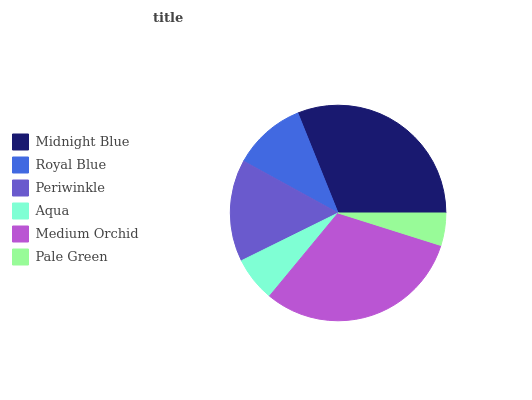Is Pale Green the minimum?
Answer yes or no. Yes. Is Medium Orchid the maximum?
Answer yes or no. Yes. Is Royal Blue the minimum?
Answer yes or no. No. Is Royal Blue the maximum?
Answer yes or no. No. Is Midnight Blue greater than Royal Blue?
Answer yes or no. Yes. Is Royal Blue less than Midnight Blue?
Answer yes or no. Yes. Is Royal Blue greater than Midnight Blue?
Answer yes or no. No. Is Midnight Blue less than Royal Blue?
Answer yes or no. No. Is Periwinkle the high median?
Answer yes or no. Yes. Is Royal Blue the low median?
Answer yes or no. Yes. Is Royal Blue the high median?
Answer yes or no. No. Is Midnight Blue the low median?
Answer yes or no. No. 